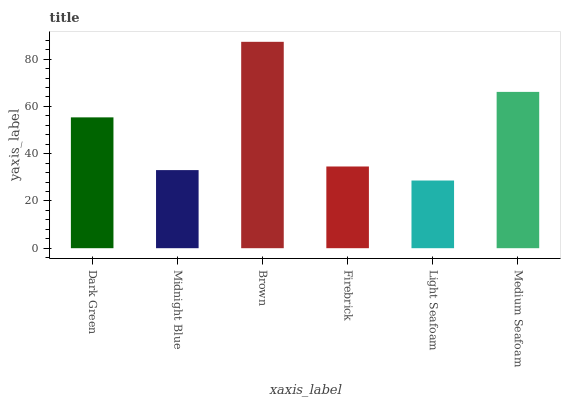Is Light Seafoam the minimum?
Answer yes or no. Yes. Is Brown the maximum?
Answer yes or no. Yes. Is Midnight Blue the minimum?
Answer yes or no. No. Is Midnight Blue the maximum?
Answer yes or no. No. Is Dark Green greater than Midnight Blue?
Answer yes or no. Yes. Is Midnight Blue less than Dark Green?
Answer yes or no. Yes. Is Midnight Blue greater than Dark Green?
Answer yes or no. No. Is Dark Green less than Midnight Blue?
Answer yes or no. No. Is Dark Green the high median?
Answer yes or no. Yes. Is Firebrick the low median?
Answer yes or no. Yes. Is Firebrick the high median?
Answer yes or no. No. Is Light Seafoam the low median?
Answer yes or no. No. 